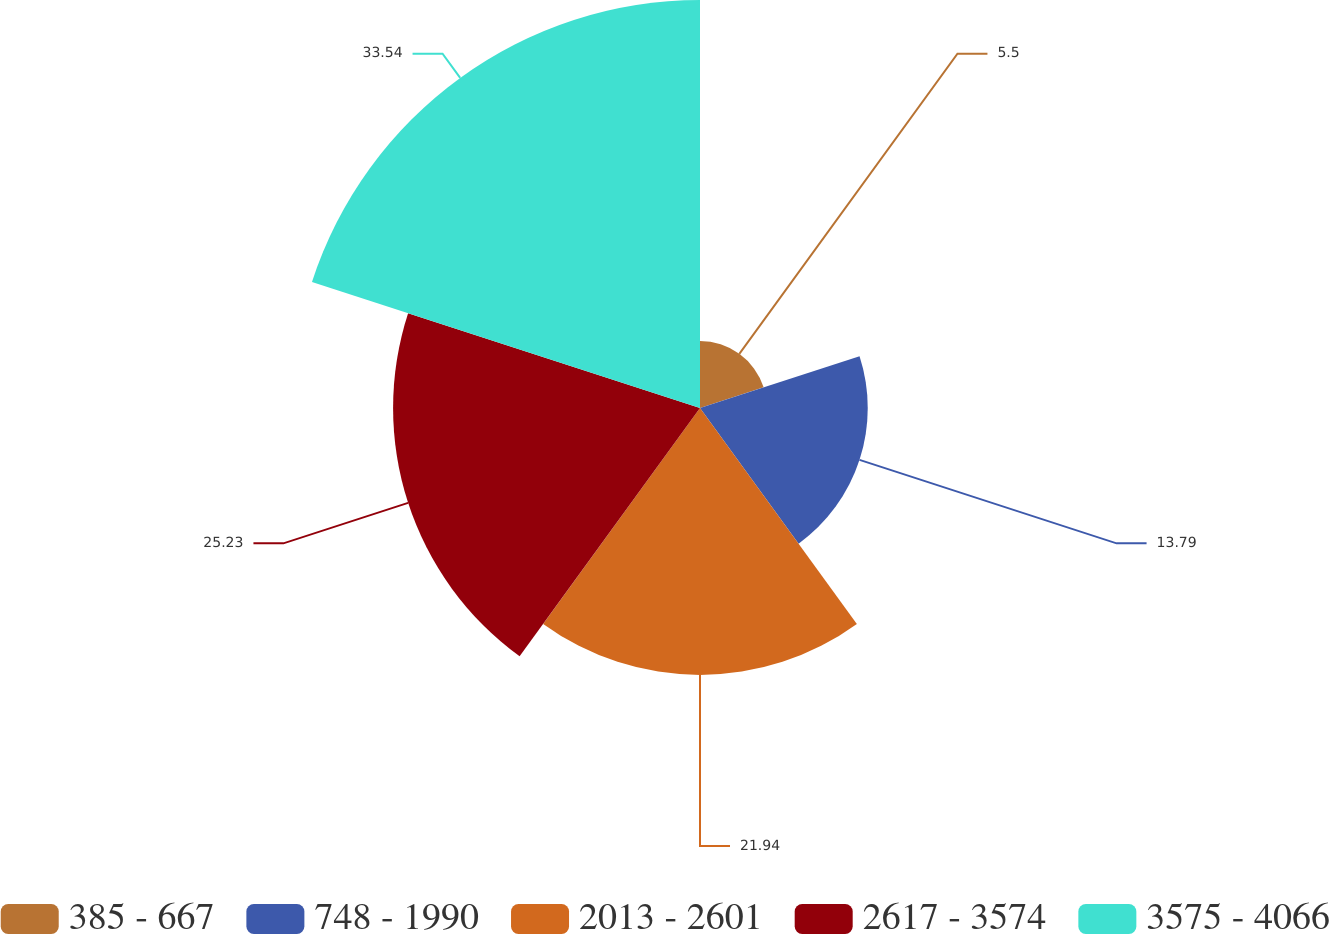Convert chart. <chart><loc_0><loc_0><loc_500><loc_500><pie_chart><fcel>385 - 667<fcel>748 - 1990<fcel>2013 - 2601<fcel>2617 - 3574<fcel>3575 - 4066<nl><fcel>5.5%<fcel>13.79%<fcel>21.94%<fcel>25.23%<fcel>33.54%<nl></chart> 